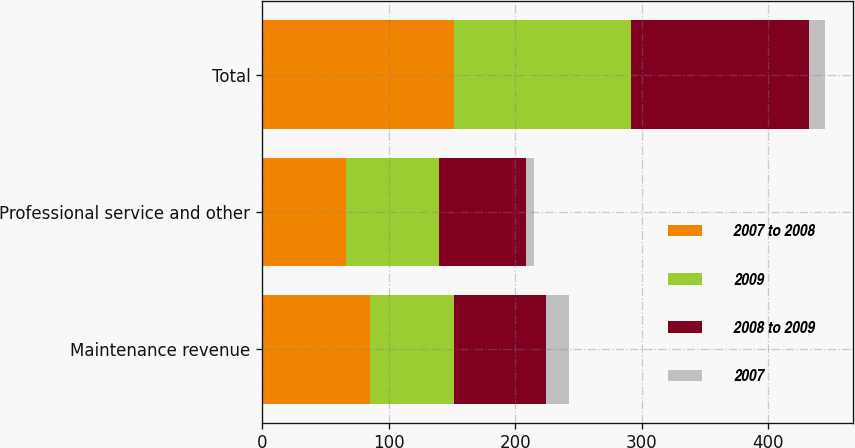Convert chart to OTSL. <chart><loc_0><loc_0><loc_500><loc_500><stacked_bar_chart><ecel><fcel>Maintenance revenue<fcel>Professional service and other<fcel>Total<nl><fcel>2007 to 2008<fcel>85.3<fcel>66.7<fcel>152<nl><fcel>2009<fcel>66.6<fcel>73.1<fcel>139.7<nl><fcel>2008 to 2009<fcel>72.2<fcel>68.7<fcel>140.9<nl><fcel>2007<fcel>18.7<fcel>6.4<fcel>12.3<nl></chart> 